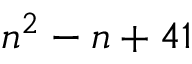Convert formula to latex. <formula><loc_0><loc_0><loc_500><loc_500>n ^ { 2 } - n + 4 1</formula> 